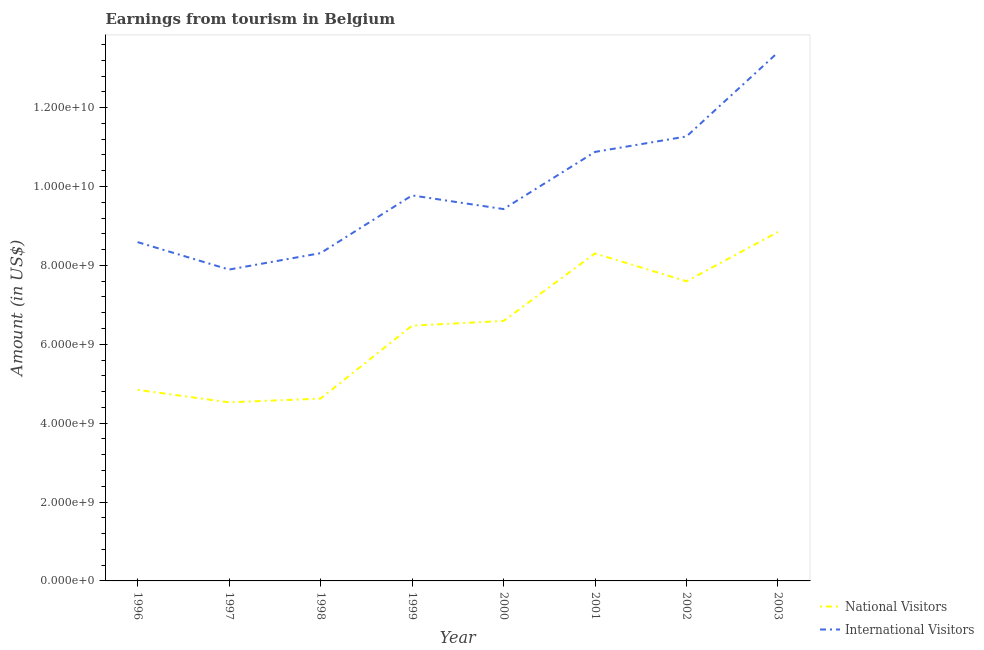How many different coloured lines are there?
Your answer should be very brief. 2. What is the amount earned from international visitors in 1999?
Your answer should be compact. 9.78e+09. Across all years, what is the maximum amount earned from international visitors?
Offer a terse response. 1.34e+1. Across all years, what is the minimum amount earned from national visitors?
Provide a succinct answer. 4.53e+09. In which year was the amount earned from national visitors minimum?
Offer a very short reply. 1997. What is the total amount earned from international visitors in the graph?
Offer a terse response. 7.96e+1. What is the difference between the amount earned from national visitors in 2001 and that in 2002?
Give a very brief answer. 7.06e+08. What is the difference between the amount earned from international visitors in 1998 and the amount earned from national visitors in 2001?
Offer a very short reply. 7.00e+06. What is the average amount earned from national visitors per year?
Ensure brevity in your answer.  6.48e+09. In the year 1996, what is the difference between the amount earned from national visitors and amount earned from international visitors?
Make the answer very short. -3.75e+09. What is the ratio of the amount earned from national visitors in 1996 to that in 2002?
Provide a succinct answer. 0.64. Is the difference between the amount earned from national visitors in 1999 and 2001 greater than the difference between the amount earned from international visitors in 1999 and 2001?
Offer a terse response. No. What is the difference between the highest and the second highest amount earned from international visitors?
Provide a succinct answer. 2.13e+09. What is the difference between the highest and the lowest amount earned from international visitors?
Your answer should be compact. 5.51e+09. Is the sum of the amount earned from international visitors in 1997 and 2000 greater than the maximum amount earned from national visitors across all years?
Provide a short and direct response. Yes. How are the legend labels stacked?
Give a very brief answer. Vertical. What is the title of the graph?
Provide a succinct answer. Earnings from tourism in Belgium. What is the label or title of the X-axis?
Your response must be concise. Year. What is the label or title of the Y-axis?
Give a very brief answer. Amount (in US$). What is the Amount (in US$) of National Visitors in 1996?
Offer a terse response. 4.84e+09. What is the Amount (in US$) of International Visitors in 1996?
Give a very brief answer. 8.59e+09. What is the Amount (in US$) of National Visitors in 1997?
Provide a succinct answer. 4.53e+09. What is the Amount (in US$) of International Visitors in 1997?
Offer a very short reply. 7.90e+09. What is the Amount (in US$) of National Visitors in 1998?
Provide a short and direct response. 4.62e+09. What is the Amount (in US$) in International Visitors in 1998?
Provide a short and direct response. 8.31e+09. What is the Amount (in US$) in National Visitors in 1999?
Offer a very short reply. 6.47e+09. What is the Amount (in US$) of International Visitors in 1999?
Provide a succinct answer. 9.78e+09. What is the Amount (in US$) of National Visitors in 2000?
Give a very brief answer. 6.59e+09. What is the Amount (in US$) in International Visitors in 2000?
Provide a short and direct response. 9.43e+09. What is the Amount (in US$) in National Visitors in 2001?
Offer a terse response. 8.30e+09. What is the Amount (in US$) in International Visitors in 2001?
Keep it short and to the point. 1.09e+1. What is the Amount (in US$) in National Visitors in 2002?
Ensure brevity in your answer.  7.60e+09. What is the Amount (in US$) of International Visitors in 2002?
Your response must be concise. 1.13e+1. What is the Amount (in US$) of National Visitors in 2003?
Make the answer very short. 8.85e+09. What is the Amount (in US$) of International Visitors in 2003?
Provide a short and direct response. 1.34e+1. Across all years, what is the maximum Amount (in US$) in National Visitors?
Your answer should be compact. 8.85e+09. Across all years, what is the maximum Amount (in US$) in International Visitors?
Make the answer very short. 1.34e+1. Across all years, what is the minimum Amount (in US$) of National Visitors?
Offer a very short reply. 4.53e+09. Across all years, what is the minimum Amount (in US$) in International Visitors?
Your answer should be very brief. 7.90e+09. What is the total Amount (in US$) in National Visitors in the graph?
Provide a short and direct response. 5.18e+1. What is the total Amount (in US$) of International Visitors in the graph?
Provide a succinct answer. 7.96e+1. What is the difference between the Amount (in US$) of National Visitors in 1996 and that in 1997?
Provide a succinct answer. 3.15e+08. What is the difference between the Amount (in US$) of International Visitors in 1996 and that in 1997?
Make the answer very short. 6.96e+08. What is the difference between the Amount (in US$) in National Visitors in 1996 and that in 1998?
Your answer should be compact. 2.21e+08. What is the difference between the Amount (in US$) in International Visitors in 1996 and that in 1998?
Your answer should be compact. 2.80e+08. What is the difference between the Amount (in US$) in National Visitors in 1996 and that in 1999?
Keep it short and to the point. -1.63e+09. What is the difference between the Amount (in US$) in International Visitors in 1996 and that in 1999?
Your answer should be compact. -1.18e+09. What is the difference between the Amount (in US$) in National Visitors in 1996 and that in 2000?
Ensure brevity in your answer.  -1.75e+09. What is the difference between the Amount (in US$) of International Visitors in 1996 and that in 2000?
Your answer should be compact. -8.38e+08. What is the difference between the Amount (in US$) in National Visitors in 1996 and that in 2001?
Keep it short and to the point. -3.46e+09. What is the difference between the Amount (in US$) of International Visitors in 1996 and that in 2001?
Your answer should be compact. -2.29e+09. What is the difference between the Amount (in US$) in National Visitors in 1996 and that in 2002?
Give a very brief answer. -2.75e+09. What is the difference between the Amount (in US$) of International Visitors in 1996 and that in 2002?
Give a very brief answer. -2.68e+09. What is the difference between the Amount (in US$) of National Visitors in 1996 and that in 2003?
Provide a short and direct response. -4.00e+09. What is the difference between the Amount (in US$) of International Visitors in 1996 and that in 2003?
Make the answer very short. -4.81e+09. What is the difference between the Amount (in US$) in National Visitors in 1997 and that in 1998?
Give a very brief answer. -9.40e+07. What is the difference between the Amount (in US$) in International Visitors in 1997 and that in 1998?
Your answer should be very brief. -4.16e+08. What is the difference between the Amount (in US$) in National Visitors in 1997 and that in 1999?
Ensure brevity in your answer.  -1.94e+09. What is the difference between the Amount (in US$) in International Visitors in 1997 and that in 1999?
Your answer should be compact. -1.88e+09. What is the difference between the Amount (in US$) in National Visitors in 1997 and that in 2000?
Make the answer very short. -2.06e+09. What is the difference between the Amount (in US$) of International Visitors in 1997 and that in 2000?
Make the answer very short. -1.53e+09. What is the difference between the Amount (in US$) of National Visitors in 1997 and that in 2001?
Give a very brief answer. -3.78e+09. What is the difference between the Amount (in US$) in International Visitors in 1997 and that in 2001?
Ensure brevity in your answer.  -2.98e+09. What is the difference between the Amount (in US$) in National Visitors in 1997 and that in 2002?
Your answer should be compact. -3.07e+09. What is the difference between the Amount (in US$) in International Visitors in 1997 and that in 2002?
Provide a succinct answer. -3.38e+09. What is the difference between the Amount (in US$) in National Visitors in 1997 and that in 2003?
Offer a very short reply. -4.32e+09. What is the difference between the Amount (in US$) of International Visitors in 1997 and that in 2003?
Keep it short and to the point. -5.51e+09. What is the difference between the Amount (in US$) of National Visitors in 1998 and that in 1999?
Your answer should be very brief. -1.85e+09. What is the difference between the Amount (in US$) of International Visitors in 1998 and that in 1999?
Provide a short and direct response. -1.46e+09. What is the difference between the Amount (in US$) of National Visitors in 1998 and that in 2000?
Make the answer very short. -1.97e+09. What is the difference between the Amount (in US$) of International Visitors in 1998 and that in 2000?
Make the answer very short. -1.12e+09. What is the difference between the Amount (in US$) of National Visitors in 1998 and that in 2001?
Provide a succinct answer. -3.68e+09. What is the difference between the Amount (in US$) in International Visitors in 1998 and that in 2001?
Ensure brevity in your answer.  -2.57e+09. What is the difference between the Amount (in US$) of National Visitors in 1998 and that in 2002?
Ensure brevity in your answer.  -2.98e+09. What is the difference between the Amount (in US$) in International Visitors in 1998 and that in 2002?
Ensure brevity in your answer.  -2.96e+09. What is the difference between the Amount (in US$) in National Visitors in 1998 and that in 2003?
Provide a short and direct response. -4.22e+09. What is the difference between the Amount (in US$) of International Visitors in 1998 and that in 2003?
Provide a short and direct response. -5.09e+09. What is the difference between the Amount (in US$) in National Visitors in 1999 and that in 2000?
Offer a terse response. -1.20e+08. What is the difference between the Amount (in US$) of International Visitors in 1999 and that in 2000?
Provide a succinct answer. 3.46e+08. What is the difference between the Amount (in US$) of National Visitors in 1999 and that in 2001?
Offer a terse response. -1.83e+09. What is the difference between the Amount (in US$) in International Visitors in 1999 and that in 2001?
Give a very brief answer. -1.10e+09. What is the difference between the Amount (in US$) in National Visitors in 1999 and that in 2002?
Your answer should be very brief. -1.13e+09. What is the difference between the Amount (in US$) of International Visitors in 1999 and that in 2002?
Keep it short and to the point. -1.50e+09. What is the difference between the Amount (in US$) of National Visitors in 1999 and that in 2003?
Provide a succinct answer. -2.38e+09. What is the difference between the Amount (in US$) in International Visitors in 1999 and that in 2003?
Give a very brief answer. -3.63e+09. What is the difference between the Amount (in US$) of National Visitors in 2000 and that in 2001?
Offer a very short reply. -1.71e+09. What is the difference between the Amount (in US$) of International Visitors in 2000 and that in 2001?
Provide a succinct answer. -1.45e+09. What is the difference between the Amount (in US$) of National Visitors in 2000 and that in 2002?
Offer a terse response. -1.01e+09. What is the difference between the Amount (in US$) in International Visitors in 2000 and that in 2002?
Offer a very short reply. -1.84e+09. What is the difference between the Amount (in US$) of National Visitors in 2000 and that in 2003?
Provide a short and direct response. -2.26e+09. What is the difference between the Amount (in US$) in International Visitors in 2000 and that in 2003?
Your answer should be very brief. -3.97e+09. What is the difference between the Amount (in US$) of National Visitors in 2001 and that in 2002?
Your answer should be very brief. 7.06e+08. What is the difference between the Amount (in US$) of International Visitors in 2001 and that in 2002?
Offer a very short reply. -3.92e+08. What is the difference between the Amount (in US$) in National Visitors in 2001 and that in 2003?
Make the answer very short. -5.44e+08. What is the difference between the Amount (in US$) of International Visitors in 2001 and that in 2003?
Give a very brief answer. -2.52e+09. What is the difference between the Amount (in US$) of National Visitors in 2002 and that in 2003?
Your answer should be compact. -1.25e+09. What is the difference between the Amount (in US$) in International Visitors in 2002 and that in 2003?
Offer a terse response. -2.13e+09. What is the difference between the Amount (in US$) in National Visitors in 1996 and the Amount (in US$) in International Visitors in 1997?
Give a very brief answer. -3.05e+09. What is the difference between the Amount (in US$) in National Visitors in 1996 and the Amount (in US$) in International Visitors in 1998?
Provide a short and direct response. -3.47e+09. What is the difference between the Amount (in US$) in National Visitors in 1996 and the Amount (in US$) in International Visitors in 1999?
Your answer should be compact. -4.93e+09. What is the difference between the Amount (in US$) in National Visitors in 1996 and the Amount (in US$) in International Visitors in 2000?
Offer a terse response. -4.58e+09. What is the difference between the Amount (in US$) of National Visitors in 1996 and the Amount (in US$) of International Visitors in 2001?
Keep it short and to the point. -6.03e+09. What is the difference between the Amount (in US$) in National Visitors in 1996 and the Amount (in US$) in International Visitors in 2002?
Your answer should be very brief. -6.43e+09. What is the difference between the Amount (in US$) of National Visitors in 1996 and the Amount (in US$) of International Visitors in 2003?
Your response must be concise. -8.56e+09. What is the difference between the Amount (in US$) of National Visitors in 1997 and the Amount (in US$) of International Visitors in 1998?
Give a very brief answer. -3.78e+09. What is the difference between the Amount (in US$) in National Visitors in 1997 and the Amount (in US$) in International Visitors in 1999?
Ensure brevity in your answer.  -5.25e+09. What is the difference between the Amount (in US$) of National Visitors in 1997 and the Amount (in US$) of International Visitors in 2000?
Provide a short and direct response. -4.90e+09. What is the difference between the Amount (in US$) of National Visitors in 1997 and the Amount (in US$) of International Visitors in 2001?
Keep it short and to the point. -6.35e+09. What is the difference between the Amount (in US$) of National Visitors in 1997 and the Amount (in US$) of International Visitors in 2002?
Give a very brief answer. -6.74e+09. What is the difference between the Amount (in US$) of National Visitors in 1997 and the Amount (in US$) of International Visitors in 2003?
Your answer should be very brief. -8.87e+09. What is the difference between the Amount (in US$) in National Visitors in 1998 and the Amount (in US$) in International Visitors in 1999?
Keep it short and to the point. -5.15e+09. What is the difference between the Amount (in US$) in National Visitors in 1998 and the Amount (in US$) in International Visitors in 2000?
Ensure brevity in your answer.  -4.81e+09. What is the difference between the Amount (in US$) in National Visitors in 1998 and the Amount (in US$) in International Visitors in 2001?
Keep it short and to the point. -6.26e+09. What is the difference between the Amount (in US$) in National Visitors in 1998 and the Amount (in US$) in International Visitors in 2002?
Provide a short and direct response. -6.65e+09. What is the difference between the Amount (in US$) of National Visitors in 1998 and the Amount (in US$) of International Visitors in 2003?
Make the answer very short. -8.78e+09. What is the difference between the Amount (in US$) of National Visitors in 1999 and the Amount (in US$) of International Visitors in 2000?
Offer a terse response. -2.96e+09. What is the difference between the Amount (in US$) in National Visitors in 1999 and the Amount (in US$) in International Visitors in 2001?
Your answer should be very brief. -4.41e+09. What is the difference between the Amount (in US$) in National Visitors in 1999 and the Amount (in US$) in International Visitors in 2002?
Your response must be concise. -4.80e+09. What is the difference between the Amount (in US$) of National Visitors in 1999 and the Amount (in US$) of International Visitors in 2003?
Your answer should be compact. -6.93e+09. What is the difference between the Amount (in US$) of National Visitors in 2000 and the Amount (in US$) of International Visitors in 2001?
Give a very brief answer. -4.29e+09. What is the difference between the Amount (in US$) in National Visitors in 2000 and the Amount (in US$) in International Visitors in 2002?
Keep it short and to the point. -4.68e+09. What is the difference between the Amount (in US$) in National Visitors in 2000 and the Amount (in US$) in International Visitors in 2003?
Ensure brevity in your answer.  -6.81e+09. What is the difference between the Amount (in US$) in National Visitors in 2001 and the Amount (in US$) in International Visitors in 2002?
Ensure brevity in your answer.  -2.97e+09. What is the difference between the Amount (in US$) of National Visitors in 2001 and the Amount (in US$) of International Visitors in 2003?
Your response must be concise. -5.10e+09. What is the difference between the Amount (in US$) in National Visitors in 2002 and the Amount (in US$) in International Visitors in 2003?
Your answer should be compact. -5.80e+09. What is the average Amount (in US$) of National Visitors per year?
Your response must be concise. 6.48e+09. What is the average Amount (in US$) of International Visitors per year?
Provide a short and direct response. 9.94e+09. In the year 1996, what is the difference between the Amount (in US$) in National Visitors and Amount (in US$) in International Visitors?
Keep it short and to the point. -3.75e+09. In the year 1997, what is the difference between the Amount (in US$) of National Visitors and Amount (in US$) of International Visitors?
Your answer should be very brief. -3.37e+09. In the year 1998, what is the difference between the Amount (in US$) of National Visitors and Amount (in US$) of International Visitors?
Offer a very short reply. -3.69e+09. In the year 1999, what is the difference between the Amount (in US$) in National Visitors and Amount (in US$) in International Visitors?
Your response must be concise. -3.30e+09. In the year 2000, what is the difference between the Amount (in US$) in National Visitors and Amount (in US$) in International Visitors?
Offer a very short reply. -2.84e+09. In the year 2001, what is the difference between the Amount (in US$) in National Visitors and Amount (in US$) in International Visitors?
Your answer should be compact. -2.57e+09. In the year 2002, what is the difference between the Amount (in US$) in National Visitors and Amount (in US$) in International Visitors?
Offer a very short reply. -3.67e+09. In the year 2003, what is the difference between the Amount (in US$) of National Visitors and Amount (in US$) of International Visitors?
Give a very brief answer. -4.55e+09. What is the ratio of the Amount (in US$) in National Visitors in 1996 to that in 1997?
Ensure brevity in your answer.  1.07. What is the ratio of the Amount (in US$) of International Visitors in 1996 to that in 1997?
Your response must be concise. 1.09. What is the ratio of the Amount (in US$) in National Visitors in 1996 to that in 1998?
Keep it short and to the point. 1.05. What is the ratio of the Amount (in US$) of International Visitors in 1996 to that in 1998?
Your answer should be very brief. 1.03. What is the ratio of the Amount (in US$) of National Visitors in 1996 to that in 1999?
Offer a terse response. 0.75. What is the ratio of the Amount (in US$) in International Visitors in 1996 to that in 1999?
Provide a short and direct response. 0.88. What is the ratio of the Amount (in US$) in National Visitors in 1996 to that in 2000?
Your answer should be compact. 0.73. What is the ratio of the Amount (in US$) of International Visitors in 1996 to that in 2000?
Keep it short and to the point. 0.91. What is the ratio of the Amount (in US$) of National Visitors in 1996 to that in 2001?
Ensure brevity in your answer.  0.58. What is the ratio of the Amount (in US$) in International Visitors in 1996 to that in 2001?
Make the answer very short. 0.79. What is the ratio of the Amount (in US$) of National Visitors in 1996 to that in 2002?
Keep it short and to the point. 0.64. What is the ratio of the Amount (in US$) in International Visitors in 1996 to that in 2002?
Give a very brief answer. 0.76. What is the ratio of the Amount (in US$) of National Visitors in 1996 to that in 2003?
Keep it short and to the point. 0.55. What is the ratio of the Amount (in US$) in International Visitors in 1996 to that in 2003?
Ensure brevity in your answer.  0.64. What is the ratio of the Amount (in US$) of National Visitors in 1997 to that in 1998?
Make the answer very short. 0.98. What is the ratio of the Amount (in US$) in International Visitors in 1997 to that in 1998?
Your response must be concise. 0.95. What is the ratio of the Amount (in US$) in National Visitors in 1997 to that in 1999?
Offer a terse response. 0.7. What is the ratio of the Amount (in US$) of International Visitors in 1997 to that in 1999?
Give a very brief answer. 0.81. What is the ratio of the Amount (in US$) in National Visitors in 1997 to that in 2000?
Provide a short and direct response. 0.69. What is the ratio of the Amount (in US$) of International Visitors in 1997 to that in 2000?
Your answer should be compact. 0.84. What is the ratio of the Amount (in US$) of National Visitors in 1997 to that in 2001?
Provide a succinct answer. 0.55. What is the ratio of the Amount (in US$) in International Visitors in 1997 to that in 2001?
Keep it short and to the point. 0.73. What is the ratio of the Amount (in US$) of National Visitors in 1997 to that in 2002?
Your response must be concise. 0.6. What is the ratio of the Amount (in US$) of International Visitors in 1997 to that in 2002?
Your answer should be compact. 0.7. What is the ratio of the Amount (in US$) in National Visitors in 1997 to that in 2003?
Keep it short and to the point. 0.51. What is the ratio of the Amount (in US$) in International Visitors in 1997 to that in 2003?
Your answer should be very brief. 0.59. What is the ratio of the Amount (in US$) of National Visitors in 1998 to that in 1999?
Give a very brief answer. 0.71. What is the ratio of the Amount (in US$) of International Visitors in 1998 to that in 1999?
Keep it short and to the point. 0.85. What is the ratio of the Amount (in US$) in National Visitors in 1998 to that in 2000?
Give a very brief answer. 0.7. What is the ratio of the Amount (in US$) in International Visitors in 1998 to that in 2000?
Keep it short and to the point. 0.88. What is the ratio of the Amount (in US$) in National Visitors in 1998 to that in 2001?
Provide a short and direct response. 0.56. What is the ratio of the Amount (in US$) in International Visitors in 1998 to that in 2001?
Make the answer very short. 0.76. What is the ratio of the Amount (in US$) of National Visitors in 1998 to that in 2002?
Your answer should be compact. 0.61. What is the ratio of the Amount (in US$) of International Visitors in 1998 to that in 2002?
Offer a terse response. 0.74. What is the ratio of the Amount (in US$) of National Visitors in 1998 to that in 2003?
Offer a terse response. 0.52. What is the ratio of the Amount (in US$) in International Visitors in 1998 to that in 2003?
Offer a terse response. 0.62. What is the ratio of the Amount (in US$) in National Visitors in 1999 to that in 2000?
Ensure brevity in your answer.  0.98. What is the ratio of the Amount (in US$) of International Visitors in 1999 to that in 2000?
Provide a succinct answer. 1.04. What is the ratio of the Amount (in US$) in National Visitors in 1999 to that in 2001?
Offer a terse response. 0.78. What is the ratio of the Amount (in US$) of International Visitors in 1999 to that in 2001?
Offer a very short reply. 0.9. What is the ratio of the Amount (in US$) in National Visitors in 1999 to that in 2002?
Provide a short and direct response. 0.85. What is the ratio of the Amount (in US$) in International Visitors in 1999 to that in 2002?
Make the answer very short. 0.87. What is the ratio of the Amount (in US$) in National Visitors in 1999 to that in 2003?
Offer a terse response. 0.73. What is the ratio of the Amount (in US$) in International Visitors in 1999 to that in 2003?
Offer a terse response. 0.73. What is the ratio of the Amount (in US$) in National Visitors in 2000 to that in 2001?
Keep it short and to the point. 0.79. What is the ratio of the Amount (in US$) in International Visitors in 2000 to that in 2001?
Offer a terse response. 0.87. What is the ratio of the Amount (in US$) of National Visitors in 2000 to that in 2002?
Make the answer very short. 0.87. What is the ratio of the Amount (in US$) of International Visitors in 2000 to that in 2002?
Your answer should be very brief. 0.84. What is the ratio of the Amount (in US$) in National Visitors in 2000 to that in 2003?
Keep it short and to the point. 0.74. What is the ratio of the Amount (in US$) in International Visitors in 2000 to that in 2003?
Offer a terse response. 0.7. What is the ratio of the Amount (in US$) in National Visitors in 2001 to that in 2002?
Your answer should be very brief. 1.09. What is the ratio of the Amount (in US$) in International Visitors in 2001 to that in 2002?
Make the answer very short. 0.97. What is the ratio of the Amount (in US$) in National Visitors in 2001 to that in 2003?
Ensure brevity in your answer.  0.94. What is the ratio of the Amount (in US$) in International Visitors in 2001 to that in 2003?
Make the answer very short. 0.81. What is the ratio of the Amount (in US$) in National Visitors in 2002 to that in 2003?
Make the answer very short. 0.86. What is the ratio of the Amount (in US$) in International Visitors in 2002 to that in 2003?
Ensure brevity in your answer.  0.84. What is the difference between the highest and the second highest Amount (in US$) in National Visitors?
Your answer should be compact. 5.44e+08. What is the difference between the highest and the second highest Amount (in US$) of International Visitors?
Make the answer very short. 2.13e+09. What is the difference between the highest and the lowest Amount (in US$) in National Visitors?
Your response must be concise. 4.32e+09. What is the difference between the highest and the lowest Amount (in US$) in International Visitors?
Ensure brevity in your answer.  5.51e+09. 